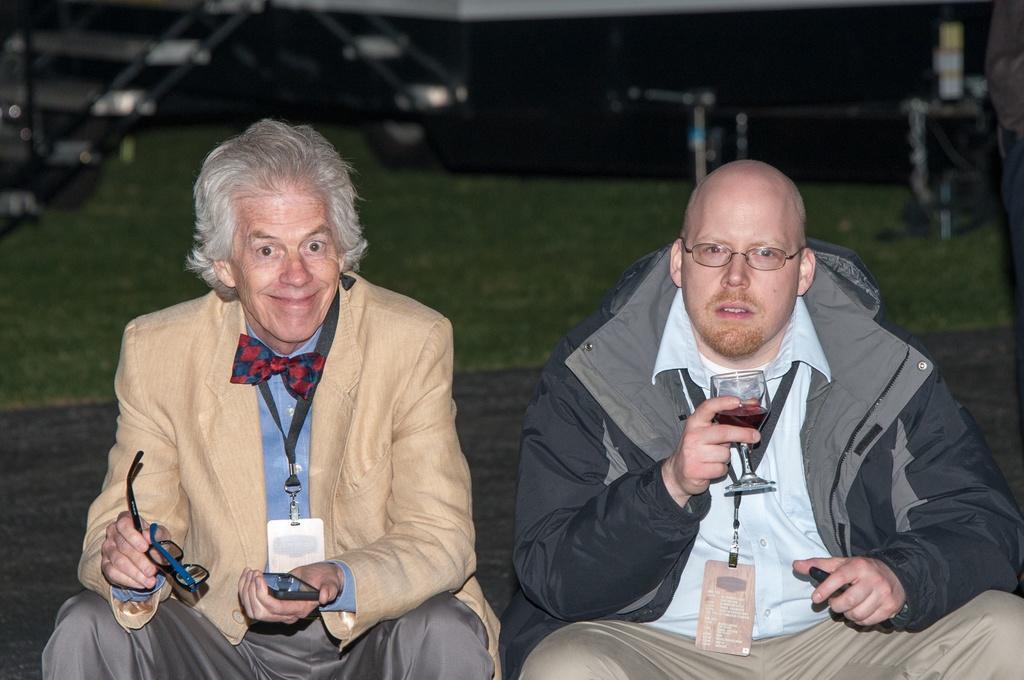Please provide a concise description of this image. In this picture there are two men one wearing black jacket and holding the glass and the other one is holding the spectacles and phone is his hand and we can see some grass. 